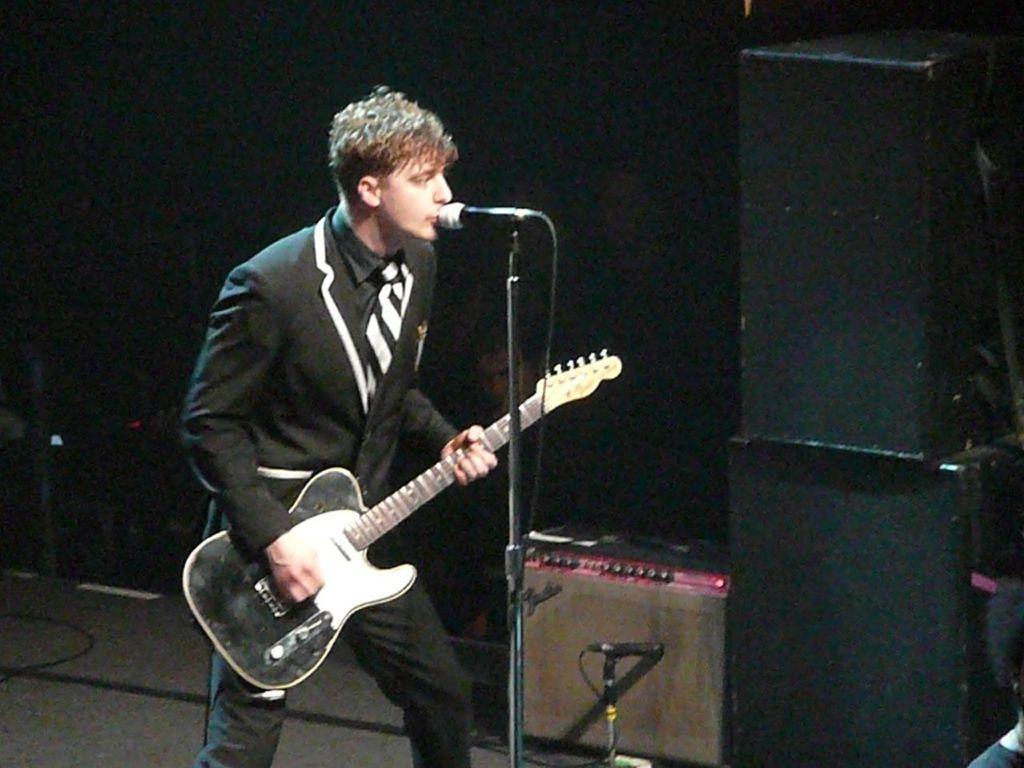Can you describe this image briefly? This image is clicked in a concert. And there are speakers on the right side. There is a person standing in the middle of the image. He is singing. There a mic in front of him and there is also a mic stand. The person is playing a guitar. He wore black jacket black and white tie and black pant. There is wire on the left side bottom corner. 